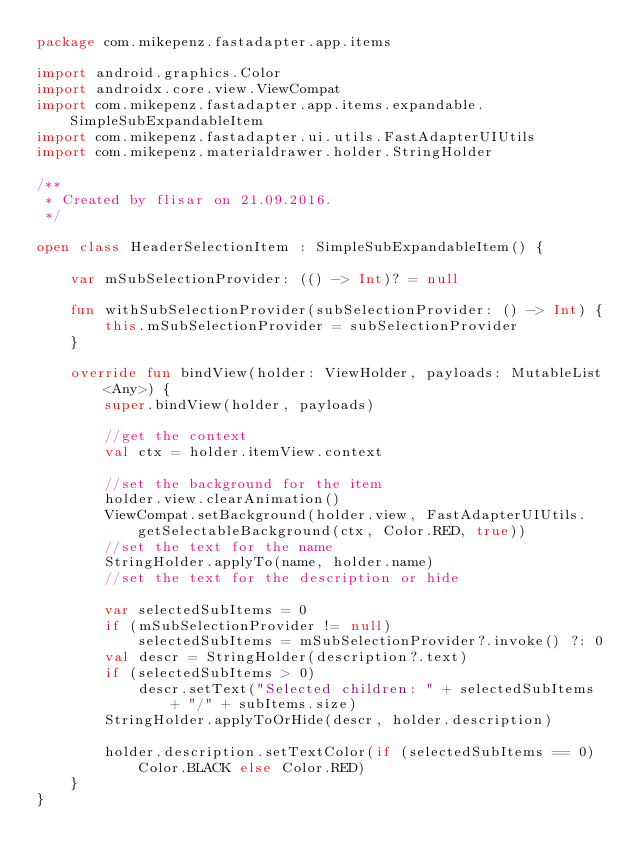Convert code to text. <code><loc_0><loc_0><loc_500><loc_500><_Kotlin_>package com.mikepenz.fastadapter.app.items

import android.graphics.Color
import androidx.core.view.ViewCompat
import com.mikepenz.fastadapter.app.items.expandable.SimpleSubExpandableItem
import com.mikepenz.fastadapter.ui.utils.FastAdapterUIUtils
import com.mikepenz.materialdrawer.holder.StringHolder

/**
 * Created by flisar on 21.09.2016.
 */

open class HeaderSelectionItem : SimpleSubExpandableItem() {

    var mSubSelectionProvider: (() -> Int)? = null

    fun withSubSelectionProvider(subSelectionProvider: () -> Int) {
        this.mSubSelectionProvider = subSelectionProvider
    }

    override fun bindView(holder: ViewHolder, payloads: MutableList<Any>) {
        super.bindView(holder, payloads)

        //get the context
        val ctx = holder.itemView.context

        //set the background for the item
        holder.view.clearAnimation()
        ViewCompat.setBackground(holder.view, FastAdapterUIUtils.getSelectableBackground(ctx, Color.RED, true))
        //set the text for the name
        StringHolder.applyTo(name, holder.name)
        //set the text for the description or hide

        var selectedSubItems = 0
        if (mSubSelectionProvider != null)
            selectedSubItems = mSubSelectionProvider?.invoke() ?: 0
        val descr = StringHolder(description?.text)
        if (selectedSubItems > 0)
            descr.setText("Selected children: " + selectedSubItems + "/" + subItems.size)
        StringHolder.applyToOrHide(descr, holder.description)

        holder.description.setTextColor(if (selectedSubItems == 0) Color.BLACK else Color.RED)
    }
}
</code> 